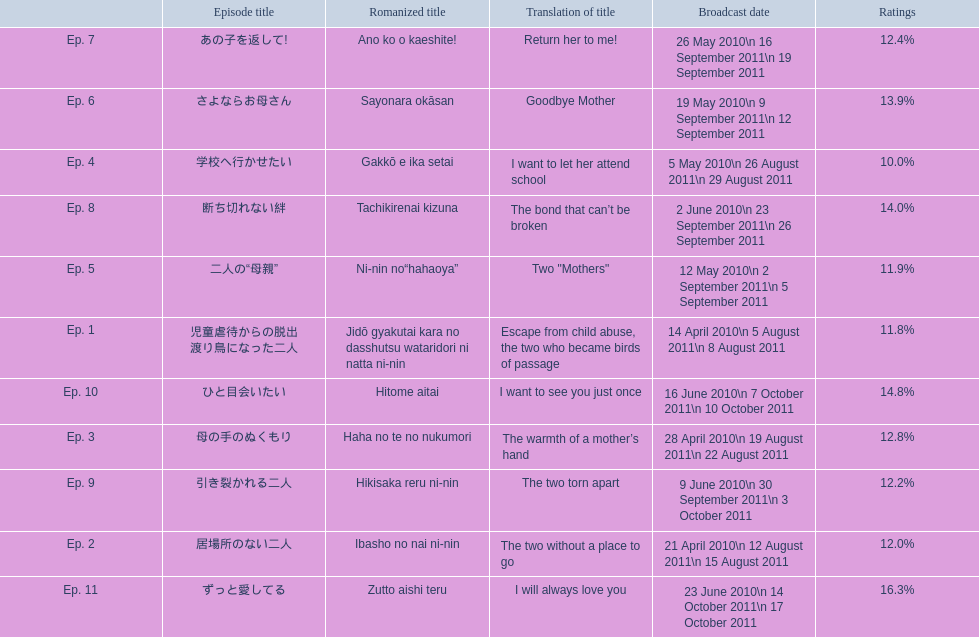Write the full table. {'header': ['', 'Episode title', 'Romanized title', 'Translation of title', 'Broadcast date', 'Ratings'], 'rows': [['Ep. 7', 'あの子を返して!', 'Ano ko o kaeshite!', 'Return her to me!', '26 May 2010\\n 16 September 2011\\n 19 September 2011', '12.4%'], ['Ep. 6', 'さよならお母さん', 'Sayonara okāsan', 'Goodbye Mother', '19 May 2010\\n 9 September 2011\\n 12 September 2011', '13.9%'], ['Ep. 4', '学校へ行かせたい', 'Gakkō e ika setai', 'I want to let her attend school', '5 May 2010\\n 26 August 2011\\n 29 August 2011', '10.0%'], ['Ep. 8', '断ち切れない絆', 'Tachikirenai kizuna', 'The bond that can’t be broken', '2 June 2010\\n 23 September 2011\\n 26 September 2011', '14.0%'], ['Ep. 5', '二人の“母親”', 'Ni-nin no“hahaoya”', 'Two "Mothers"', '12 May 2010\\n 2 September 2011\\n 5 September 2011', '11.9%'], ['Ep. 1', '児童虐待からの脱出 渡り鳥になった二人', 'Jidō gyakutai kara no dasshutsu wataridori ni natta ni-nin', 'Escape from child abuse, the two who became birds of passage', '14 April 2010\\n 5 August 2011\\n 8 August 2011', '11.8%'], ['Ep. 10', 'ひと目会いたい', 'Hitome aitai', 'I want to see you just once', '16 June 2010\\n 7 October 2011\\n 10 October 2011', '14.8%'], ['Ep. 3', '母の手のぬくもり', 'Haha no te no nukumori', 'The warmth of a mother’s hand', '28 April 2010\\n 19 August 2011\\n 22 August 2011', '12.8%'], ['Ep. 9', '引き裂かれる二人', 'Hikisaka reru ni-nin', 'The two torn apart', '9 June 2010\\n 30 September 2011\\n 3 October 2011', '12.2%'], ['Ep. 2', '居場所のない二人', 'Ibasho no nai ni-nin', 'The two without a place to go', '21 April 2010\\n 12 August 2011\\n 15 August 2011', '12.0%'], ['Ep. 11', 'ずっと愛してる', 'Zutto aishi teru', 'I will always love you', '23 June 2010\\n 14 October 2011\\n 17 October 2011', '16.3%']]} What was the top rated episode of this show? ずっと愛してる. 